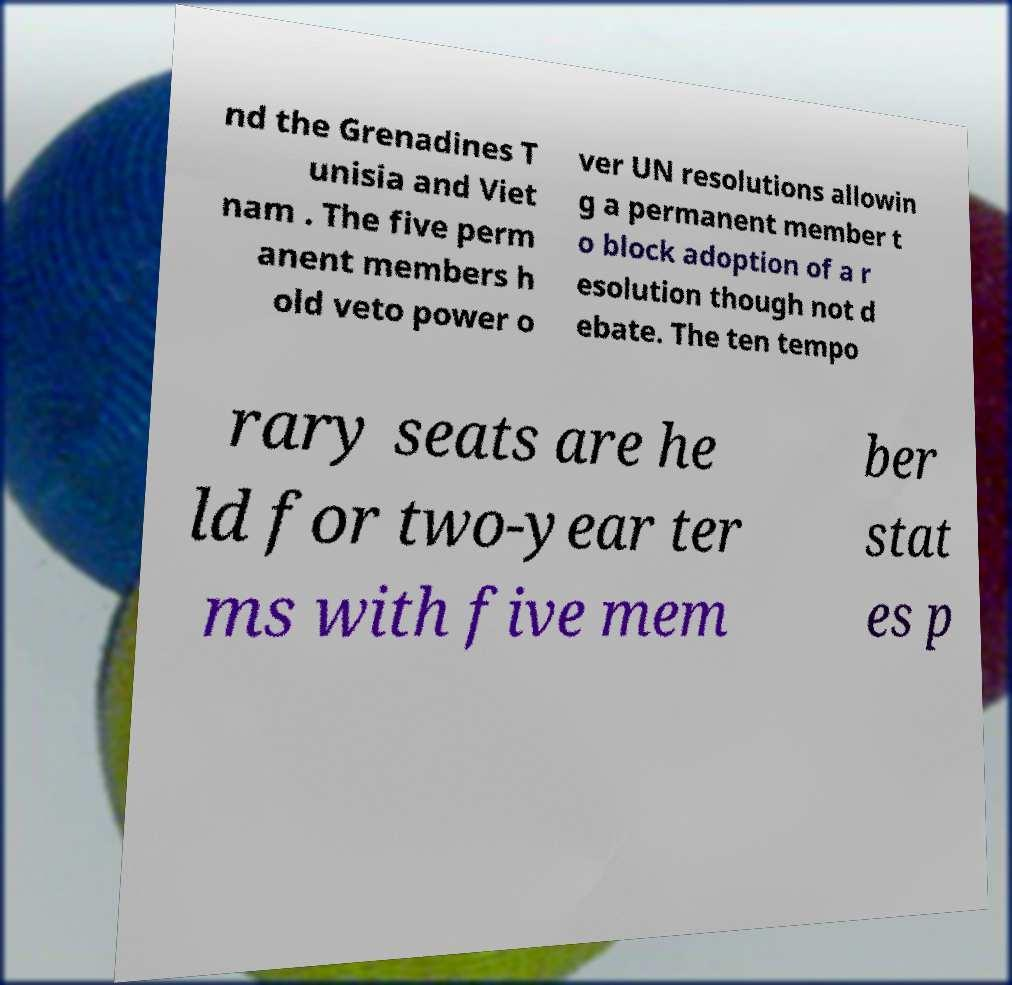What messages or text are displayed in this image? I need them in a readable, typed format. nd the Grenadines T unisia and Viet nam . The five perm anent members h old veto power o ver UN resolutions allowin g a permanent member t o block adoption of a r esolution though not d ebate. The ten tempo rary seats are he ld for two-year ter ms with five mem ber stat es p 